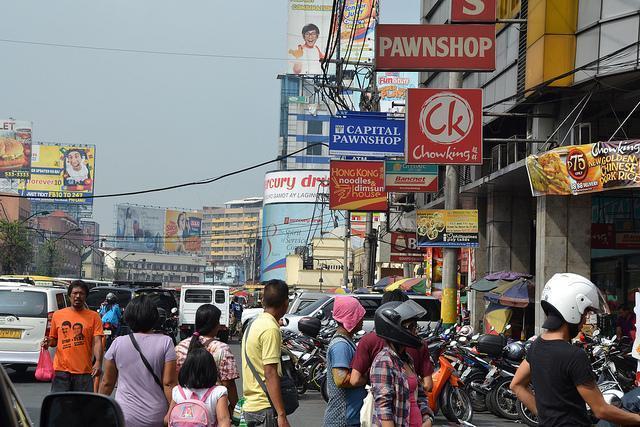How many pawn shop signs can be seen?
Give a very brief answer. 2. How many people are there?
Give a very brief answer. 7. How many cars are there?
Give a very brief answer. 2. How many motorcycles are there?
Give a very brief answer. 2. 